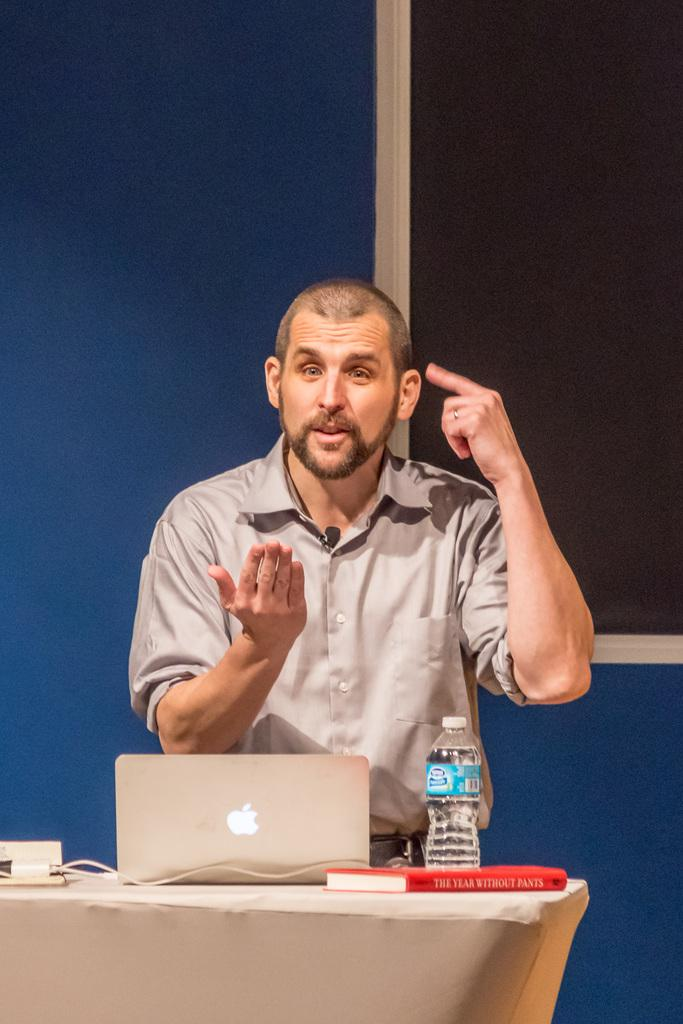What is the man in the image doing? The man is standing in front of a table. What can be seen on the table in the image? There is a laptop, a water bottle, a book, and other objects on the table. Can you describe the laptop in the image? The laptop is on the table. What might the man be using the laptop for? It is not clear from the image what the man is using the laptop for. Reasoning: Let' Let's think step by step in order to produce the conversation. We start by identifying the main subject in the image, which is the man standing in front of a table. Then, we describe the objects on the table, including a laptop, water bottle, book, and other objects. We avoid making assumptions about the man's actions or intentions and focus on the facts provided. Absurd Question/Answer: What type of ghost can be seen interacting with the laptop in the image? There is no ghost present in the image; it features a man standing in front of a table with various objects. What kind of bird is perched on the water bottle in the image? There is no bird present in the image; it only shows a man standing in front of a table with a water bottle, laptop, and other objects. What type of ghost can be seen interacting with the laptop in the image? There is no ghost present in the image; it features a man standing in front of a table with various objects. What kind of bird is perched on the water bottle in the image? There is no bird present in the image; it only shows a man standing in front of a table with a water bottle, laptop, and other objects. 